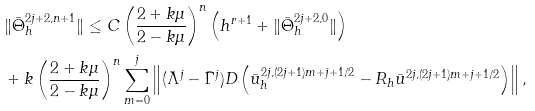<formula> <loc_0><loc_0><loc_500><loc_500>& \| \bar { \Theta } ^ { 2 j + 2 , n + 1 } _ { h } \| \leq C \left ( \frac { 2 + k \mu } { 2 - k \mu } \right ) ^ { n } \left ( h ^ { r + 1 } + \| \bar { \Theta } ^ { 2 j + 2 , 0 } _ { h } \| \right ) \\ & + k \left ( \frac { 2 + k \mu } { 2 - k \mu } \right ) ^ { n } \sum _ { m = 0 } ^ { j } \left \| ( \bar { \Lambda } ^ { j } - \bar { \Gamma } ^ { j } ) D \left ( \bar { u } ^ { 2 j , ( 2 j + 1 ) m + j + 1 / 2 } _ { h } - R _ { h } \bar { u } ^ { 2 j , ( 2 j + 1 ) m + j + 1 / 2 } \right ) \right \| ,</formula> 